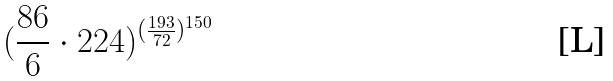<formula> <loc_0><loc_0><loc_500><loc_500>( \frac { 8 6 } { 6 } \cdot 2 2 4 ) ^ { ( \frac { 1 9 3 } { 7 2 } ) ^ { 1 5 0 } }</formula> 